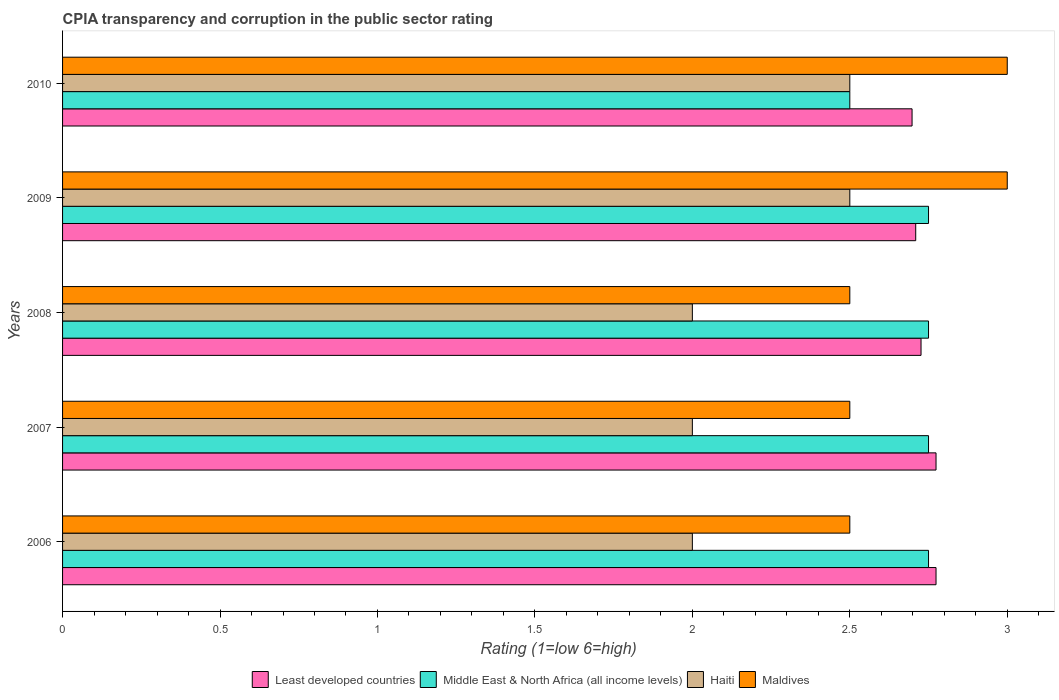How many different coloured bars are there?
Provide a succinct answer. 4. Are the number of bars per tick equal to the number of legend labels?
Provide a succinct answer. Yes. How many bars are there on the 1st tick from the top?
Make the answer very short. 4. How many bars are there on the 2nd tick from the bottom?
Provide a succinct answer. 4. In how many cases, is the number of bars for a given year not equal to the number of legend labels?
Your answer should be very brief. 0. What is the CPIA rating in Least developed countries in 2010?
Provide a succinct answer. 2.7. Across all years, what is the maximum CPIA rating in Middle East & North Africa (all income levels)?
Offer a terse response. 2.75. Across all years, what is the minimum CPIA rating in Middle East & North Africa (all income levels)?
Give a very brief answer. 2.5. What is the total CPIA rating in Middle East & North Africa (all income levels) in the graph?
Provide a succinct answer. 13.5. What is the difference between the CPIA rating in Maldives in 2007 and that in 2009?
Make the answer very short. -0.5. In the year 2006, what is the difference between the CPIA rating in Haiti and CPIA rating in Least developed countries?
Make the answer very short. -0.77. In how many years, is the CPIA rating in Least developed countries greater than 2.7 ?
Provide a succinct answer. 4. What is the ratio of the CPIA rating in Least developed countries in 2007 to that in 2008?
Your answer should be very brief. 1.02. Is the difference between the CPIA rating in Haiti in 2008 and 2009 greater than the difference between the CPIA rating in Least developed countries in 2008 and 2009?
Keep it short and to the point. No. What is the difference between the highest and the lowest CPIA rating in Haiti?
Offer a terse response. 0.5. What does the 4th bar from the top in 2006 represents?
Ensure brevity in your answer.  Least developed countries. What does the 4th bar from the bottom in 2006 represents?
Offer a terse response. Maldives. Are all the bars in the graph horizontal?
Ensure brevity in your answer.  Yes. What is the difference between two consecutive major ticks on the X-axis?
Give a very brief answer. 0.5. Are the values on the major ticks of X-axis written in scientific E-notation?
Your answer should be compact. No. Does the graph contain any zero values?
Offer a terse response. No. Does the graph contain grids?
Make the answer very short. No. What is the title of the graph?
Your response must be concise. CPIA transparency and corruption in the public sector rating. What is the label or title of the Y-axis?
Keep it short and to the point. Years. What is the Rating (1=low 6=high) of Least developed countries in 2006?
Ensure brevity in your answer.  2.77. What is the Rating (1=low 6=high) in Middle East & North Africa (all income levels) in 2006?
Your answer should be very brief. 2.75. What is the Rating (1=low 6=high) of Haiti in 2006?
Provide a succinct answer. 2. What is the Rating (1=low 6=high) of Maldives in 2006?
Your response must be concise. 2.5. What is the Rating (1=low 6=high) in Least developed countries in 2007?
Your answer should be compact. 2.77. What is the Rating (1=low 6=high) of Middle East & North Africa (all income levels) in 2007?
Ensure brevity in your answer.  2.75. What is the Rating (1=low 6=high) in Least developed countries in 2008?
Provide a short and direct response. 2.73. What is the Rating (1=low 6=high) in Middle East & North Africa (all income levels) in 2008?
Make the answer very short. 2.75. What is the Rating (1=low 6=high) in Haiti in 2008?
Your response must be concise. 2. What is the Rating (1=low 6=high) in Maldives in 2008?
Offer a terse response. 2.5. What is the Rating (1=low 6=high) in Least developed countries in 2009?
Ensure brevity in your answer.  2.71. What is the Rating (1=low 6=high) of Middle East & North Africa (all income levels) in 2009?
Offer a very short reply. 2.75. What is the Rating (1=low 6=high) in Maldives in 2009?
Your response must be concise. 3. What is the Rating (1=low 6=high) in Least developed countries in 2010?
Give a very brief answer. 2.7. Across all years, what is the maximum Rating (1=low 6=high) in Least developed countries?
Your answer should be very brief. 2.77. Across all years, what is the maximum Rating (1=low 6=high) of Middle East & North Africa (all income levels)?
Ensure brevity in your answer.  2.75. Across all years, what is the maximum Rating (1=low 6=high) of Maldives?
Offer a very short reply. 3. Across all years, what is the minimum Rating (1=low 6=high) in Least developed countries?
Give a very brief answer. 2.7. Across all years, what is the minimum Rating (1=low 6=high) in Haiti?
Provide a short and direct response. 2. What is the total Rating (1=low 6=high) in Least developed countries in the graph?
Your answer should be compact. 13.68. What is the total Rating (1=low 6=high) in Maldives in the graph?
Ensure brevity in your answer.  13.5. What is the difference between the Rating (1=low 6=high) in Least developed countries in 2006 and that in 2007?
Your response must be concise. 0. What is the difference between the Rating (1=low 6=high) of Middle East & North Africa (all income levels) in 2006 and that in 2007?
Your response must be concise. 0. What is the difference between the Rating (1=low 6=high) of Haiti in 2006 and that in 2007?
Keep it short and to the point. 0. What is the difference between the Rating (1=low 6=high) in Least developed countries in 2006 and that in 2008?
Provide a succinct answer. 0.05. What is the difference between the Rating (1=low 6=high) in Haiti in 2006 and that in 2008?
Keep it short and to the point. 0. What is the difference between the Rating (1=low 6=high) in Least developed countries in 2006 and that in 2009?
Your answer should be compact. 0.06. What is the difference between the Rating (1=low 6=high) in Least developed countries in 2006 and that in 2010?
Your response must be concise. 0.08. What is the difference between the Rating (1=low 6=high) in Haiti in 2006 and that in 2010?
Make the answer very short. -0.5. What is the difference between the Rating (1=low 6=high) of Least developed countries in 2007 and that in 2008?
Keep it short and to the point. 0.05. What is the difference between the Rating (1=low 6=high) in Middle East & North Africa (all income levels) in 2007 and that in 2008?
Give a very brief answer. 0. What is the difference between the Rating (1=low 6=high) in Maldives in 2007 and that in 2008?
Offer a very short reply. 0. What is the difference between the Rating (1=low 6=high) in Least developed countries in 2007 and that in 2009?
Offer a terse response. 0.06. What is the difference between the Rating (1=low 6=high) of Middle East & North Africa (all income levels) in 2007 and that in 2009?
Provide a succinct answer. 0. What is the difference between the Rating (1=low 6=high) of Maldives in 2007 and that in 2009?
Offer a terse response. -0.5. What is the difference between the Rating (1=low 6=high) in Least developed countries in 2007 and that in 2010?
Offer a terse response. 0.08. What is the difference between the Rating (1=low 6=high) of Middle East & North Africa (all income levels) in 2007 and that in 2010?
Offer a very short reply. 0.25. What is the difference between the Rating (1=low 6=high) of Haiti in 2007 and that in 2010?
Offer a very short reply. -0.5. What is the difference between the Rating (1=low 6=high) in Maldives in 2007 and that in 2010?
Offer a terse response. -0.5. What is the difference between the Rating (1=low 6=high) of Least developed countries in 2008 and that in 2009?
Your answer should be very brief. 0.02. What is the difference between the Rating (1=low 6=high) in Least developed countries in 2008 and that in 2010?
Give a very brief answer. 0.03. What is the difference between the Rating (1=low 6=high) in Middle East & North Africa (all income levels) in 2008 and that in 2010?
Keep it short and to the point. 0.25. What is the difference between the Rating (1=low 6=high) in Haiti in 2008 and that in 2010?
Provide a succinct answer. -0.5. What is the difference between the Rating (1=low 6=high) in Maldives in 2008 and that in 2010?
Keep it short and to the point. -0.5. What is the difference between the Rating (1=low 6=high) of Least developed countries in 2009 and that in 2010?
Offer a terse response. 0.01. What is the difference between the Rating (1=low 6=high) in Middle East & North Africa (all income levels) in 2009 and that in 2010?
Your answer should be compact. 0.25. What is the difference between the Rating (1=low 6=high) in Least developed countries in 2006 and the Rating (1=low 6=high) in Middle East & North Africa (all income levels) in 2007?
Your response must be concise. 0.02. What is the difference between the Rating (1=low 6=high) in Least developed countries in 2006 and the Rating (1=low 6=high) in Haiti in 2007?
Provide a succinct answer. 0.77. What is the difference between the Rating (1=low 6=high) of Least developed countries in 2006 and the Rating (1=low 6=high) of Maldives in 2007?
Offer a very short reply. 0.27. What is the difference between the Rating (1=low 6=high) in Middle East & North Africa (all income levels) in 2006 and the Rating (1=low 6=high) in Haiti in 2007?
Keep it short and to the point. 0.75. What is the difference between the Rating (1=low 6=high) in Haiti in 2006 and the Rating (1=low 6=high) in Maldives in 2007?
Your answer should be compact. -0.5. What is the difference between the Rating (1=low 6=high) of Least developed countries in 2006 and the Rating (1=low 6=high) of Middle East & North Africa (all income levels) in 2008?
Offer a very short reply. 0.02. What is the difference between the Rating (1=low 6=high) in Least developed countries in 2006 and the Rating (1=low 6=high) in Haiti in 2008?
Provide a short and direct response. 0.77. What is the difference between the Rating (1=low 6=high) in Least developed countries in 2006 and the Rating (1=low 6=high) in Maldives in 2008?
Make the answer very short. 0.27. What is the difference between the Rating (1=low 6=high) of Least developed countries in 2006 and the Rating (1=low 6=high) of Middle East & North Africa (all income levels) in 2009?
Give a very brief answer. 0.02. What is the difference between the Rating (1=low 6=high) of Least developed countries in 2006 and the Rating (1=low 6=high) of Haiti in 2009?
Give a very brief answer. 0.27. What is the difference between the Rating (1=low 6=high) of Least developed countries in 2006 and the Rating (1=low 6=high) of Maldives in 2009?
Make the answer very short. -0.23. What is the difference between the Rating (1=low 6=high) of Least developed countries in 2006 and the Rating (1=low 6=high) of Middle East & North Africa (all income levels) in 2010?
Provide a succinct answer. 0.27. What is the difference between the Rating (1=low 6=high) in Least developed countries in 2006 and the Rating (1=low 6=high) in Haiti in 2010?
Offer a terse response. 0.27. What is the difference between the Rating (1=low 6=high) in Least developed countries in 2006 and the Rating (1=low 6=high) in Maldives in 2010?
Offer a very short reply. -0.23. What is the difference between the Rating (1=low 6=high) in Haiti in 2006 and the Rating (1=low 6=high) in Maldives in 2010?
Provide a short and direct response. -1. What is the difference between the Rating (1=low 6=high) of Least developed countries in 2007 and the Rating (1=low 6=high) of Middle East & North Africa (all income levels) in 2008?
Offer a terse response. 0.02. What is the difference between the Rating (1=low 6=high) in Least developed countries in 2007 and the Rating (1=low 6=high) in Haiti in 2008?
Your answer should be very brief. 0.77. What is the difference between the Rating (1=low 6=high) in Least developed countries in 2007 and the Rating (1=low 6=high) in Maldives in 2008?
Provide a succinct answer. 0.27. What is the difference between the Rating (1=low 6=high) in Haiti in 2007 and the Rating (1=low 6=high) in Maldives in 2008?
Your answer should be very brief. -0.5. What is the difference between the Rating (1=low 6=high) of Least developed countries in 2007 and the Rating (1=low 6=high) of Middle East & North Africa (all income levels) in 2009?
Provide a succinct answer. 0.02. What is the difference between the Rating (1=low 6=high) in Least developed countries in 2007 and the Rating (1=low 6=high) in Haiti in 2009?
Make the answer very short. 0.27. What is the difference between the Rating (1=low 6=high) of Least developed countries in 2007 and the Rating (1=low 6=high) of Maldives in 2009?
Your answer should be very brief. -0.23. What is the difference between the Rating (1=low 6=high) in Least developed countries in 2007 and the Rating (1=low 6=high) in Middle East & North Africa (all income levels) in 2010?
Keep it short and to the point. 0.27. What is the difference between the Rating (1=low 6=high) in Least developed countries in 2007 and the Rating (1=low 6=high) in Haiti in 2010?
Keep it short and to the point. 0.27. What is the difference between the Rating (1=low 6=high) of Least developed countries in 2007 and the Rating (1=low 6=high) of Maldives in 2010?
Give a very brief answer. -0.23. What is the difference between the Rating (1=low 6=high) in Middle East & North Africa (all income levels) in 2007 and the Rating (1=low 6=high) in Haiti in 2010?
Your answer should be very brief. 0.25. What is the difference between the Rating (1=low 6=high) in Least developed countries in 2008 and the Rating (1=low 6=high) in Middle East & North Africa (all income levels) in 2009?
Offer a very short reply. -0.02. What is the difference between the Rating (1=low 6=high) in Least developed countries in 2008 and the Rating (1=low 6=high) in Haiti in 2009?
Ensure brevity in your answer.  0.23. What is the difference between the Rating (1=low 6=high) of Least developed countries in 2008 and the Rating (1=low 6=high) of Maldives in 2009?
Provide a short and direct response. -0.27. What is the difference between the Rating (1=low 6=high) of Middle East & North Africa (all income levels) in 2008 and the Rating (1=low 6=high) of Haiti in 2009?
Give a very brief answer. 0.25. What is the difference between the Rating (1=low 6=high) in Middle East & North Africa (all income levels) in 2008 and the Rating (1=low 6=high) in Maldives in 2009?
Give a very brief answer. -0.25. What is the difference between the Rating (1=low 6=high) in Least developed countries in 2008 and the Rating (1=low 6=high) in Middle East & North Africa (all income levels) in 2010?
Provide a short and direct response. 0.23. What is the difference between the Rating (1=low 6=high) of Least developed countries in 2008 and the Rating (1=low 6=high) of Haiti in 2010?
Keep it short and to the point. 0.23. What is the difference between the Rating (1=low 6=high) of Least developed countries in 2008 and the Rating (1=low 6=high) of Maldives in 2010?
Make the answer very short. -0.27. What is the difference between the Rating (1=low 6=high) of Middle East & North Africa (all income levels) in 2008 and the Rating (1=low 6=high) of Haiti in 2010?
Your response must be concise. 0.25. What is the difference between the Rating (1=low 6=high) in Middle East & North Africa (all income levels) in 2008 and the Rating (1=low 6=high) in Maldives in 2010?
Give a very brief answer. -0.25. What is the difference between the Rating (1=low 6=high) in Least developed countries in 2009 and the Rating (1=low 6=high) in Middle East & North Africa (all income levels) in 2010?
Your answer should be compact. 0.21. What is the difference between the Rating (1=low 6=high) of Least developed countries in 2009 and the Rating (1=low 6=high) of Haiti in 2010?
Your answer should be very brief. 0.21. What is the difference between the Rating (1=low 6=high) in Least developed countries in 2009 and the Rating (1=low 6=high) in Maldives in 2010?
Give a very brief answer. -0.29. What is the average Rating (1=low 6=high) of Least developed countries per year?
Your answer should be very brief. 2.74. What is the average Rating (1=low 6=high) of Haiti per year?
Make the answer very short. 2.2. In the year 2006, what is the difference between the Rating (1=low 6=high) in Least developed countries and Rating (1=low 6=high) in Middle East & North Africa (all income levels)?
Offer a very short reply. 0.02. In the year 2006, what is the difference between the Rating (1=low 6=high) of Least developed countries and Rating (1=low 6=high) of Haiti?
Provide a succinct answer. 0.77. In the year 2006, what is the difference between the Rating (1=low 6=high) in Least developed countries and Rating (1=low 6=high) in Maldives?
Give a very brief answer. 0.27. In the year 2006, what is the difference between the Rating (1=low 6=high) in Haiti and Rating (1=low 6=high) in Maldives?
Keep it short and to the point. -0.5. In the year 2007, what is the difference between the Rating (1=low 6=high) of Least developed countries and Rating (1=low 6=high) of Middle East & North Africa (all income levels)?
Give a very brief answer. 0.02. In the year 2007, what is the difference between the Rating (1=low 6=high) of Least developed countries and Rating (1=low 6=high) of Haiti?
Provide a succinct answer. 0.77. In the year 2007, what is the difference between the Rating (1=low 6=high) of Least developed countries and Rating (1=low 6=high) of Maldives?
Keep it short and to the point. 0.27. In the year 2007, what is the difference between the Rating (1=low 6=high) of Middle East & North Africa (all income levels) and Rating (1=low 6=high) of Haiti?
Your response must be concise. 0.75. In the year 2007, what is the difference between the Rating (1=low 6=high) in Middle East & North Africa (all income levels) and Rating (1=low 6=high) in Maldives?
Your answer should be very brief. 0.25. In the year 2007, what is the difference between the Rating (1=low 6=high) of Haiti and Rating (1=low 6=high) of Maldives?
Your answer should be compact. -0.5. In the year 2008, what is the difference between the Rating (1=low 6=high) in Least developed countries and Rating (1=low 6=high) in Middle East & North Africa (all income levels)?
Provide a succinct answer. -0.02. In the year 2008, what is the difference between the Rating (1=low 6=high) in Least developed countries and Rating (1=low 6=high) in Haiti?
Offer a terse response. 0.73. In the year 2008, what is the difference between the Rating (1=low 6=high) in Least developed countries and Rating (1=low 6=high) in Maldives?
Offer a terse response. 0.23. In the year 2008, what is the difference between the Rating (1=low 6=high) in Haiti and Rating (1=low 6=high) in Maldives?
Offer a very short reply. -0.5. In the year 2009, what is the difference between the Rating (1=low 6=high) in Least developed countries and Rating (1=low 6=high) in Middle East & North Africa (all income levels)?
Keep it short and to the point. -0.04. In the year 2009, what is the difference between the Rating (1=low 6=high) in Least developed countries and Rating (1=low 6=high) in Haiti?
Keep it short and to the point. 0.21. In the year 2009, what is the difference between the Rating (1=low 6=high) in Least developed countries and Rating (1=low 6=high) in Maldives?
Your answer should be compact. -0.29. In the year 2009, what is the difference between the Rating (1=low 6=high) in Middle East & North Africa (all income levels) and Rating (1=low 6=high) in Maldives?
Keep it short and to the point. -0.25. In the year 2009, what is the difference between the Rating (1=low 6=high) in Haiti and Rating (1=low 6=high) in Maldives?
Ensure brevity in your answer.  -0.5. In the year 2010, what is the difference between the Rating (1=low 6=high) in Least developed countries and Rating (1=low 6=high) in Middle East & North Africa (all income levels)?
Provide a short and direct response. 0.2. In the year 2010, what is the difference between the Rating (1=low 6=high) of Least developed countries and Rating (1=low 6=high) of Haiti?
Your response must be concise. 0.2. In the year 2010, what is the difference between the Rating (1=low 6=high) of Least developed countries and Rating (1=low 6=high) of Maldives?
Offer a terse response. -0.3. In the year 2010, what is the difference between the Rating (1=low 6=high) in Middle East & North Africa (all income levels) and Rating (1=low 6=high) in Haiti?
Keep it short and to the point. 0. What is the ratio of the Rating (1=low 6=high) of Middle East & North Africa (all income levels) in 2006 to that in 2007?
Your answer should be compact. 1. What is the ratio of the Rating (1=low 6=high) of Haiti in 2006 to that in 2007?
Offer a very short reply. 1. What is the ratio of the Rating (1=low 6=high) in Maldives in 2006 to that in 2007?
Provide a short and direct response. 1. What is the ratio of the Rating (1=low 6=high) of Least developed countries in 2006 to that in 2008?
Your answer should be compact. 1.02. What is the ratio of the Rating (1=low 6=high) of Middle East & North Africa (all income levels) in 2006 to that in 2008?
Your response must be concise. 1. What is the ratio of the Rating (1=low 6=high) of Haiti in 2006 to that in 2008?
Make the answer very short. 1. What is the ratio of the Rating (1=low 6=high) of Maldives in 2006 to that in 2008?
Keep it short and to the point. 1. What is the ratio of the Rating (1=low 6=high) of Least developed countries in 2006 to that in 2009?
Your answer should be very brief. 1.02. What is the ratio of the Rating (1=low 6=high) of Middle East & North Africa (all income levels) in 2006 to that in 2009?
Offer a very short reply. 1. What is the ratio of the Rating (1=low 6=high) in Maldives in 2006 to that in 2009?
Offer a very short reply. 0.83. What is the ratio of the Rating (1=low 6=high) of Least developed countries in 2006 to that in 2010?
Offer a terse response. 1.03. What is the ratio of the Rating (1=low 6=high) of Middle East & North Africa (all income levels) in 2006 to that in 2010?
Your response must be concise. 1.1. What is the ratio of the Rating (1=low 6=high) of Haiti in 2006 to that in 2010?
Provide a short and direct response. 0.8. What is the ratio of the Rating (1=low 6=high) of Least developed countries in 2007 to that in 2008?
Provide a succinct answer. 1.02. What is the ratio of the Rating (1=low 6=high) of Middle East & North Africa (all income levels) in 2007 to that in 2008?
Provide a short and direct response. 1. What is the ratio of the Rating (1=low 6=high) of Maldives in 2007 to that in 2008?
Your response must be concise. 1. What is the ratio of the Rating (1=low 6=high) in Least developed countries in 2007 to that in 2009?
Your response must be concise. 1.02. What is the ratio of the Rating (1=low 6=high) of Least developed countries in 2007 to that in 2010?
Offer a very short reply. 1.03. What is the ratio of the Rating (1=low 6=high) in Middle East & North Africa (all income levels) in 2007 to that in 2010?
Your answer should be compact. 1.1. What is the ratio of the Rating (1=low 6=high) in Haiti in 2007 to that in 2010?
Provide a short and direct response. 0.8. What is the ratio of the Rating (1=low 6=high) of Maldives in 2007 to that in 2010?
Give a very brief answer. 0.83. What is the ratio of the Rating (1=low 6=high) of Middle East & North Africa (all income levels) in 2008 to that in 2009?
Provide a succinct answer. 1. What is the ratio of the Rating (1=low 6=high) in Haiti in 2008 to that in 2009?
Your answer should be compact. 0.8. What is the ratio of the Rating (1=low 6=high) in Least developed countries in 2008 to that in 2010?
Keep it short and to the point. 1.01. What is the ratio of the Rating (1=low 6=high) of Middle East & North Africa (all income levels) in 2009 to that in 2010?
Make the answer very short. 1.1. What is the difference between the highest and the second highest Rating (1=low 6=high) in Least developed countries?
Provide a short and direct response. 0. What is the difference between the highest and the second highest Rating (1=low 6=high) of Middle East & North Africa (all income levels)?
Provide a short and direct response. 0. What is the difference between the highest and the second highest Rating (1=low 6=high) of Maldives?
Give a very brief answer. 0. What is the difference between the highest and the lowest Rating (1=low 6=high) in Least developed countries?
Keep it short and to the point. 0.08. What is the difference between the highest and the lowest Rating (1=low 6=high) in Middle East & North Africa (all income levels)?
Make the answer very short. 0.25. What is the difference between the highest and the lowest Rating (1=low 6=high) in Maldives?
Offer a very short reply. 0.5. 